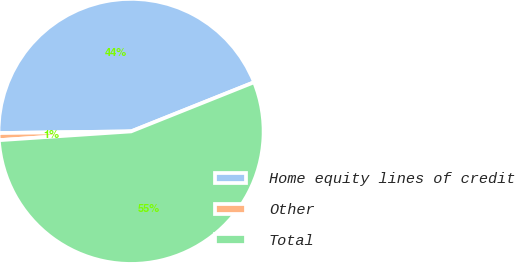Convert chart. <chart><loc_0><loc_0><loc_500><loc_500><pie_chart><fcel>Home equity lines of credit<fcel>Other<fcel>Total<nl><fcel>44.14%<fcel>0.86%<fcel>54.99%<nl></chart> 